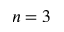Convert formula to latex. <formula><loc_0><loc_0><loc_500><loc_500>n = 3</formula> 